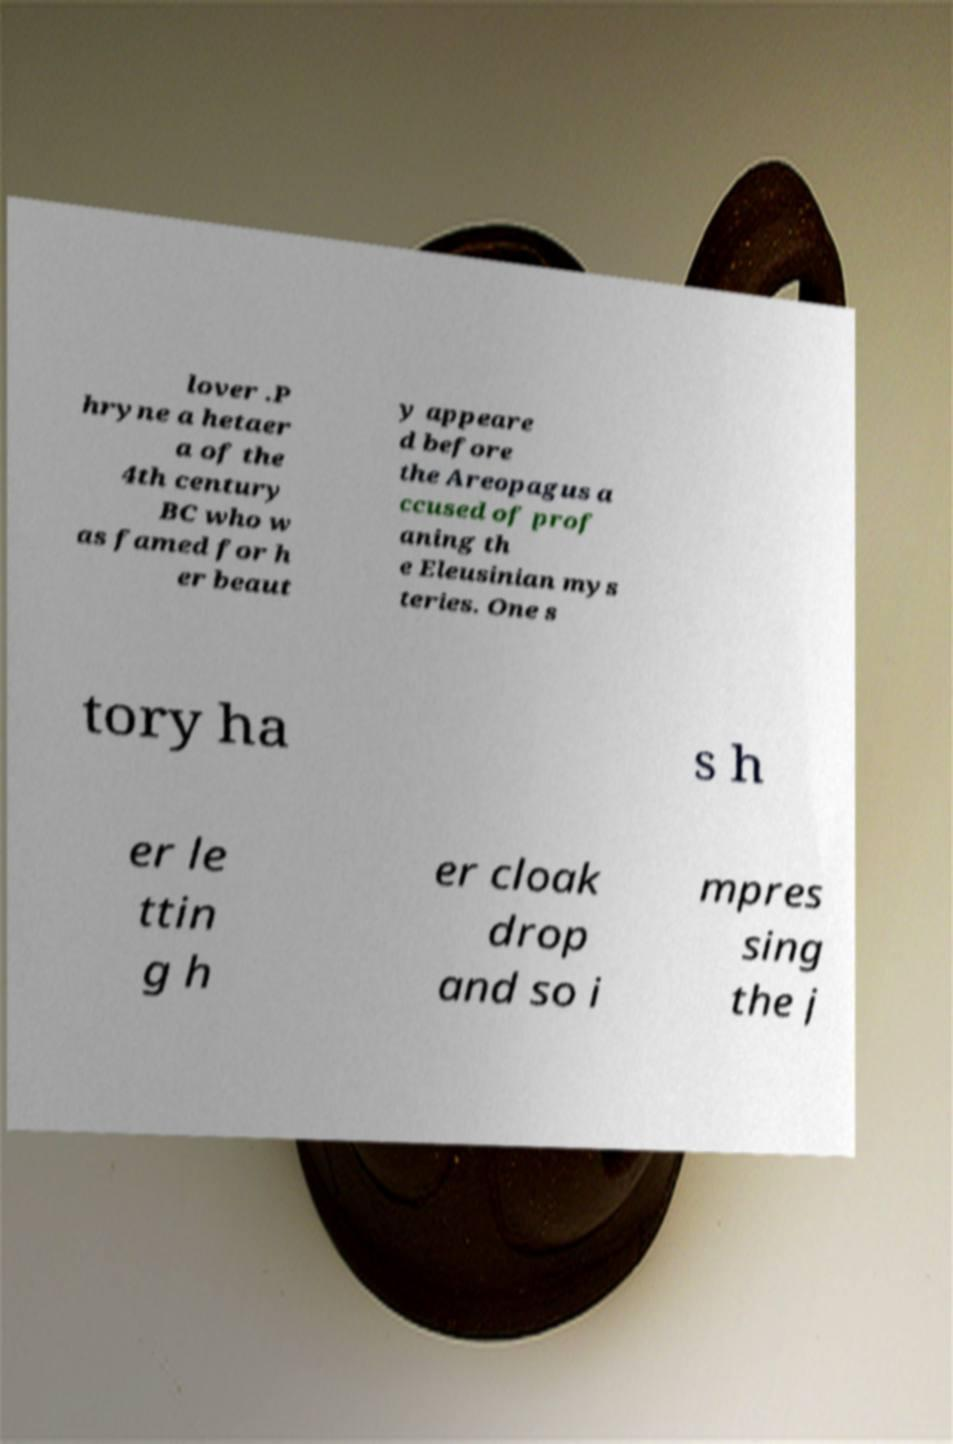What messages or text are displayed in this image? I need them in a readable, typed format. lover .P hryne a hetaer a of the 4th century BC who w as famed for h er beaut y appeare d before the Areopagus a ccused of prof aning th e Eleusinian mys teries. One s tory ha s h er le ttin g h er cloak drop and so i mpres sing the j 